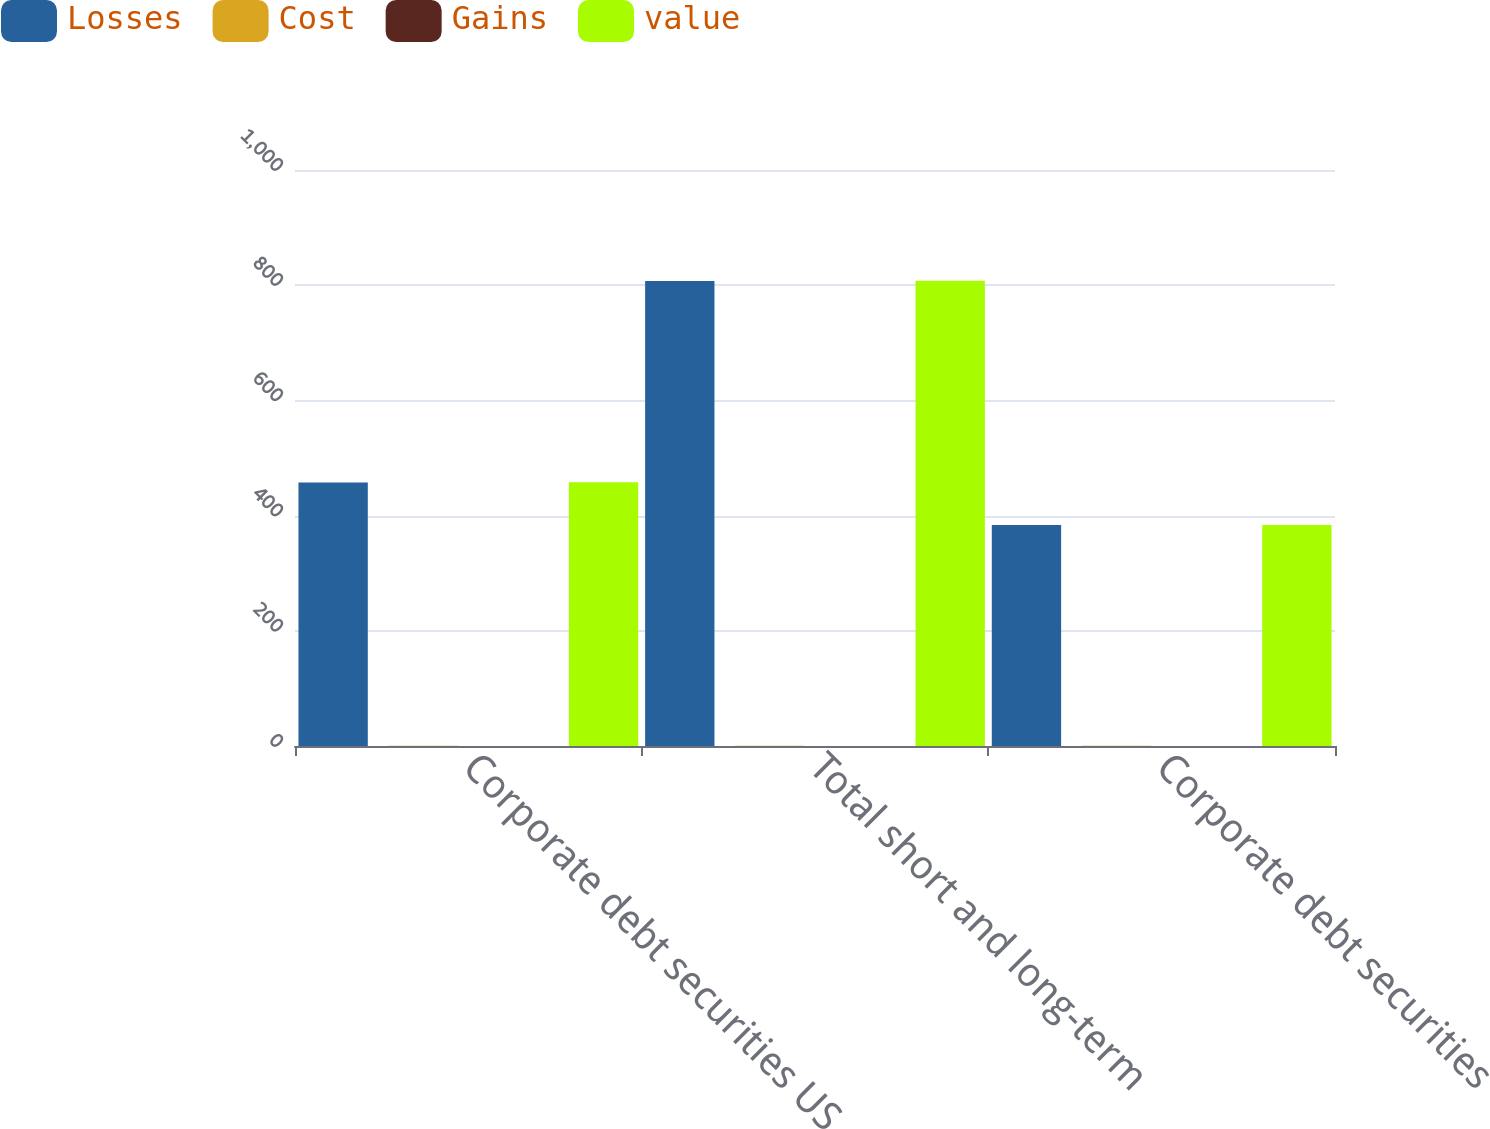Convert chart. <chart><loc_0><loc_0><loc_500><loc_500><stacked_bar_chart><ecel><fcel>Corporate debt securities US<fcel>Total short and long-term<fcel>Corporate debt securities<nl><fcel>Losses<fcel>457.6<fcel>807.3<fcel>383.6<nl><fcel>Cost<fcel>0.4<fcel>0.5<fcel>0.3<nl><fcel>Gains<fcel>0.1<fcel>0.1<fcel>0.1<nl><fcel>value<fcel>457.9<fcel>807.7<fcel>383.8<nl></chart> 